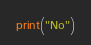Convert code to text. <code><loc_0><loc_0><loc_500><loc_500><_Python_>print("No")</code> 